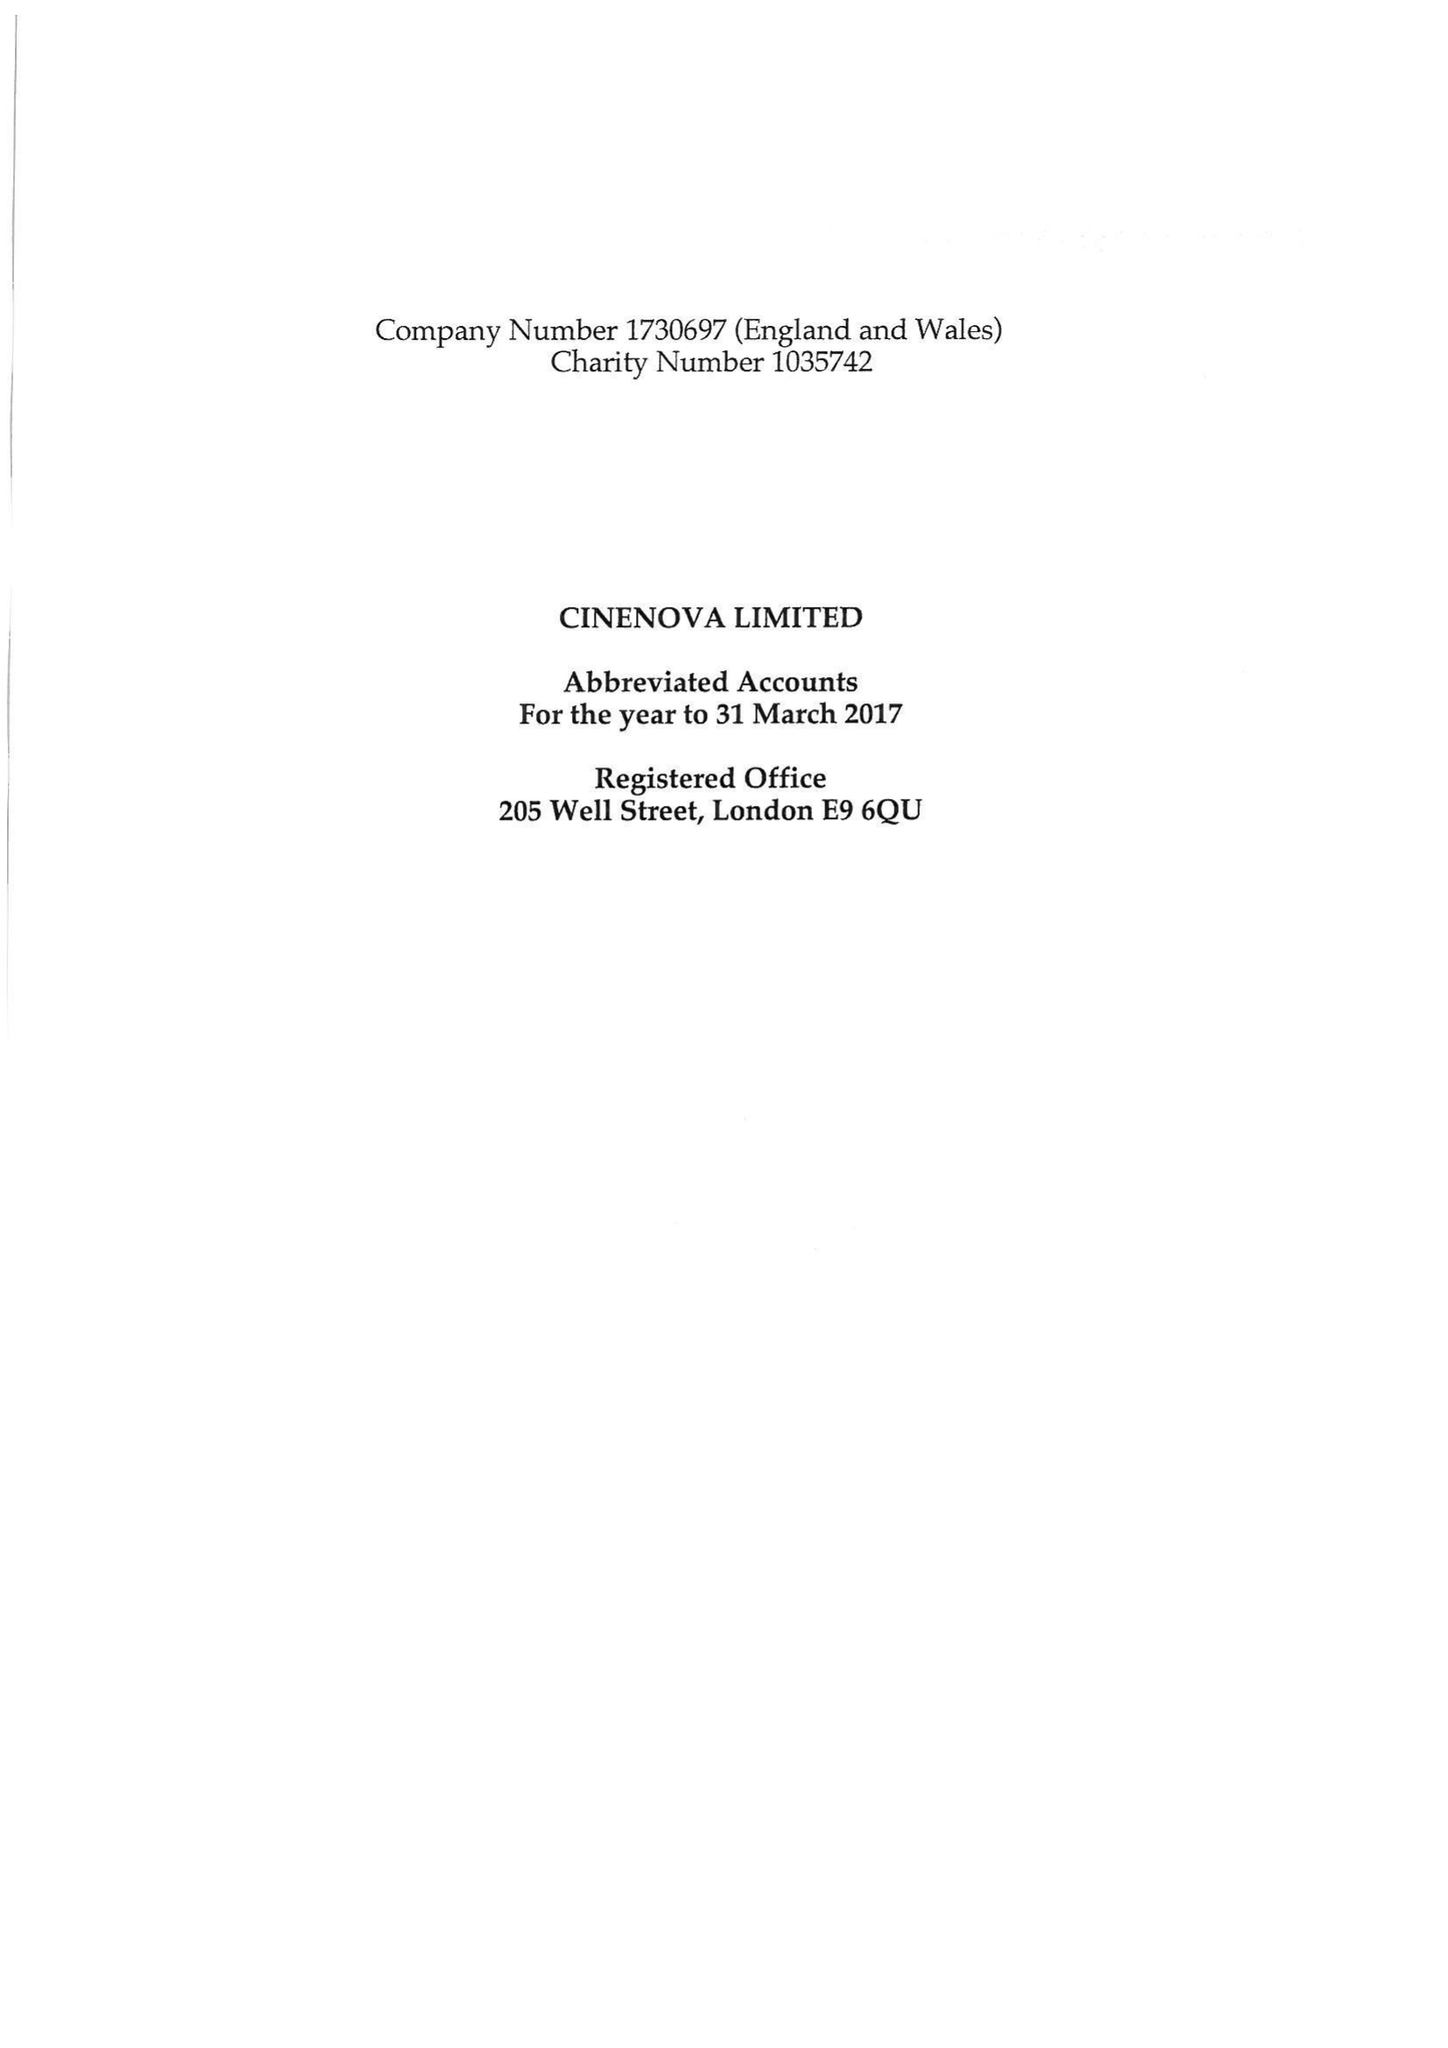What is the value for the address__post_town?
Answer the question using a single word or phrase. LONDON 